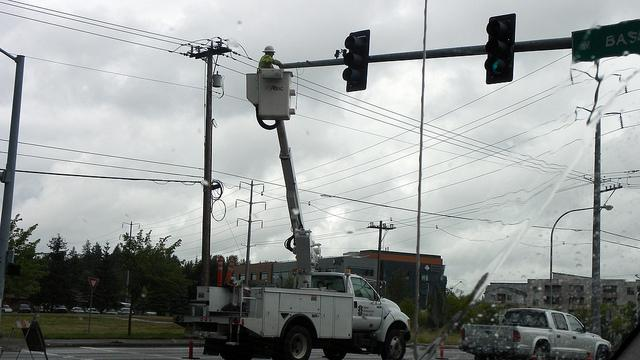What sort of repairs in the lifted person doing?

Choices:
A) animal remediation
B) pothole
C) electrical
D) road sign electrical 